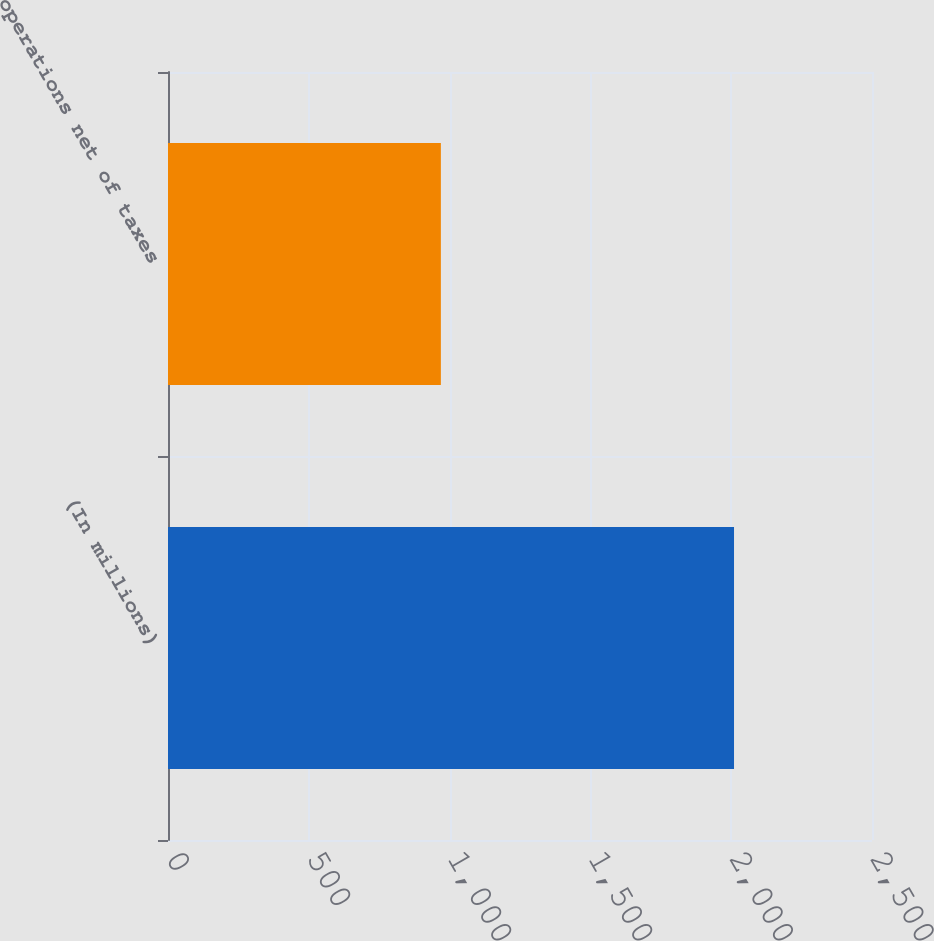Convert chart. <chart><loc_0><loc_0><loc_500><loc_500><bar_chart><fcel>(In millions)<fcel>operations net of taxes<nl><fcel>2010<fcel>969<nl></chart> 